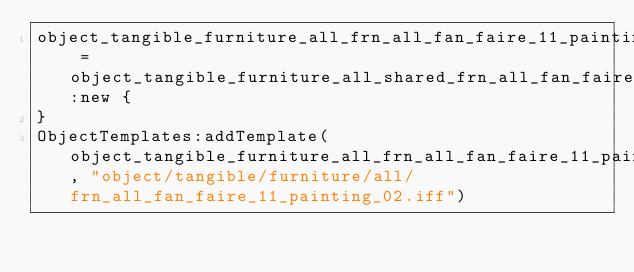<code> <loc_0><loc_0><loc_500><loc_500><_Lua_>object_tangible_furniture_all_frn_all_fan_faire_11_painting_02 = object_tangible_furniture_all_shared_frn_all_fan_faire_11_painting_02:new {
}
ObjectTemplates:addTemplate(object_tangible_furniture_all_frn_all_fan_faire_11_painting_02, "object/tangible/furniture/all/frn_all_fan_faire_11_painting_02.iff")
</code> 